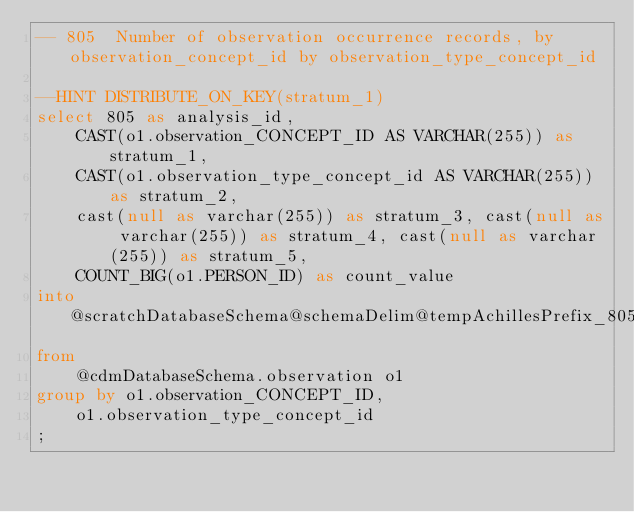<code> <loc_0><loc_0><loc_500><loc_500><_SQL_>-- 805	Number of observation occurrence records, by observation_concept_id by observation_type_concept_id

--HINT DISTRIBUTE_ON_KEY(stratum_1)
select 805 as analysis_id, 
	CAST(o1.observation_CONCEPT_ID AS VARCHAR(255)) as stratum_1,
	CAST(o1.observation_type_concept_id AS VARCHAR(255)) as stratum_2,
	cast(null as varchar(255)) as stratum_3, cast(null as varchar(255)) as stratum_4, cast(null as varchar(255)) as stratum_5,
	COUNT_BIG(o1.PERSON_ID) as count_value
into @scratchDatabaseSchema@schemaDelim@tempAchillesPrefix_805
from
	@cdmDatabaseSchema.observation o1
group by o1.observation_CONCEPT_ID,	
	o1.observation_type_concept_id
;
</code> 